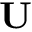Convert formula to latex. <formula><loc_0><loc_0><loc_500><loc_500>U</formula> 